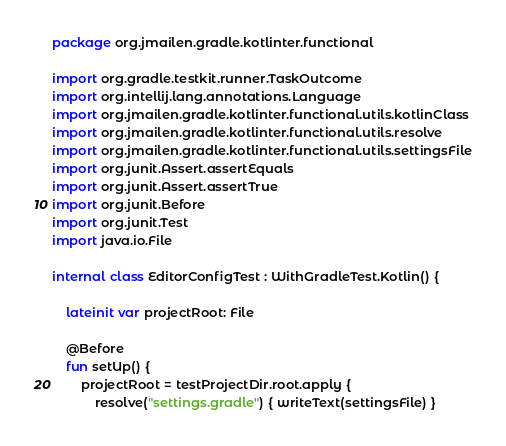<code> <loc_0><loc_0><loc_500><loc_500><_Kotlin_>package org.jmailen.gradle.kotlinter.functional

import org.gradle.testkit.runner.TaskOutcome
import org.intellij.lang.annotations.Language
import org.jmailen.gradle.kotlinter.functional.utils.kotlinClass
import org.jmailen.gradle.kotlinter.functional.utils.resolve
import org.jmailen.gradle.kotlinter.functional.utils.settingsFile
import org.junit.Assert.assertEquals
import org.junit.Assert.assertTrue
import org.junit.Before
import org.junit.Test
import java.io.File

internal class EditorConfigTest : WithGradleTest.Kotlin() {

    lateinit var projectRoot: File

    @Before
    fun setUp() {
        projectRoot = testProjectDir.root.apply {
            resolve("settings.gradle") { writeText(settingsFile) }</code> 